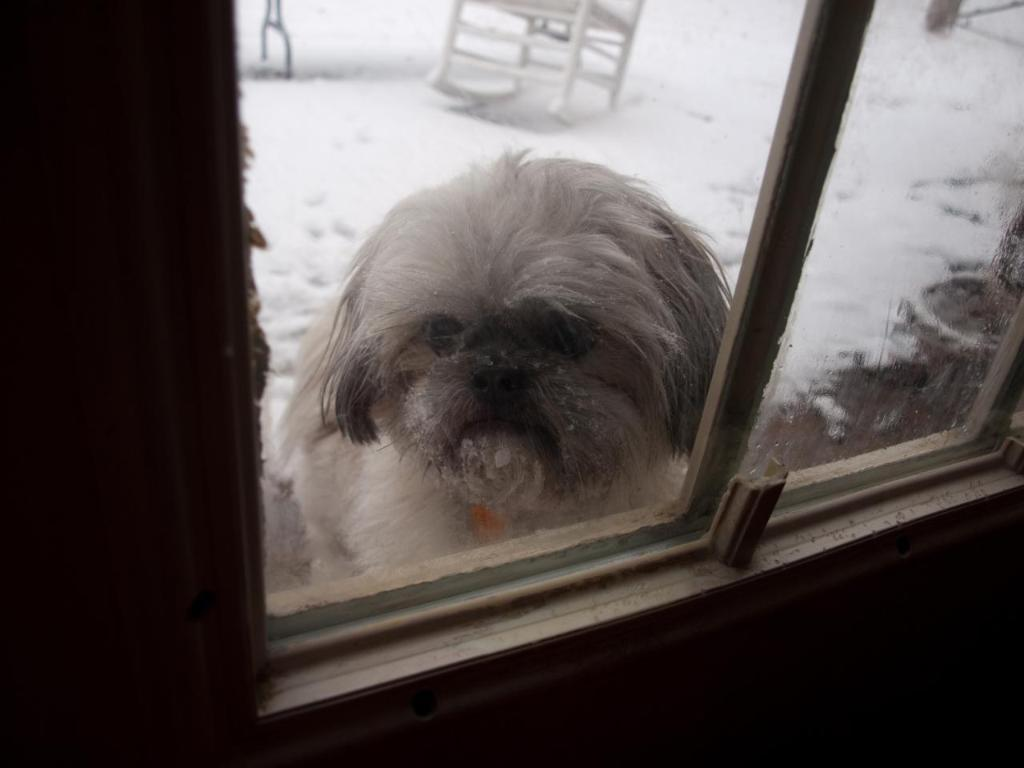What type of material is used for the windows in the image? The windows in the image are made of glass. What can be seen through the windows? A white color dog is visible through the windows. What is the weather like in the background of the image? There is snow in the background, indicating a cold or wintry environment. What else can be seen in the background of the image? There are additional objects visible in the background, but their specific nature is not mentioned in the facts. Who is the expert in the image that is providing attention to the expansion of the windows? There is no expert or expansion of windows mentioned in the image. The focus is on the glass windows, a white color dog visible through them, and the snowy background. 